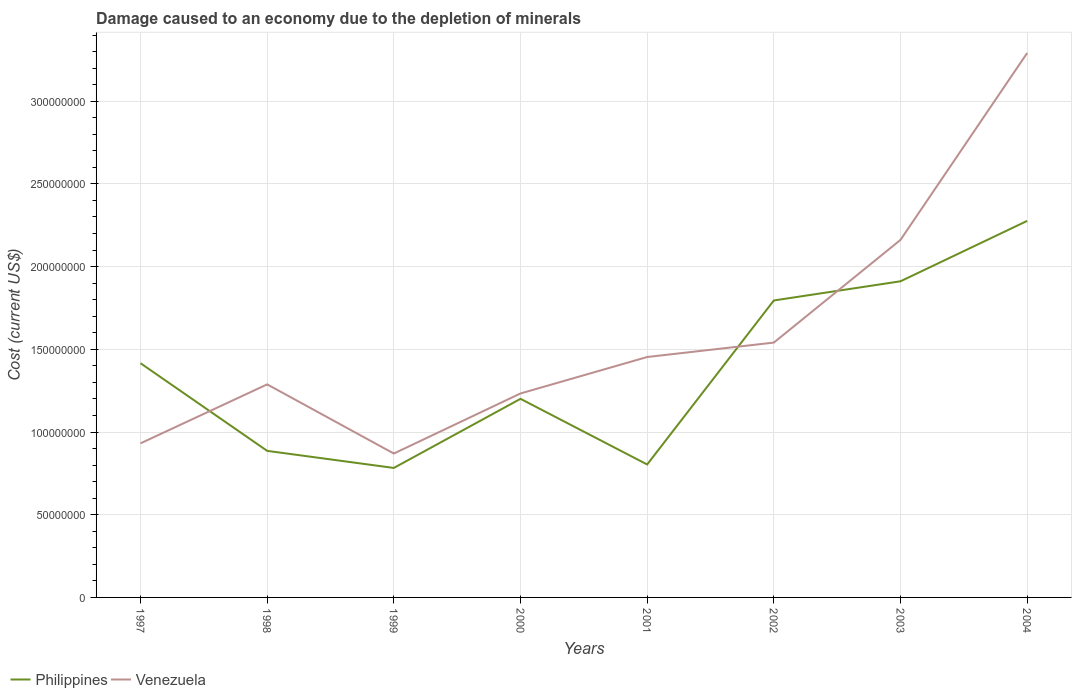Does the line corresponding to Philippines intersect with the line corresponding to Venezuela?
Ensure brevity in your answer.  Yes. Across all years, what is the maximum cost of damage caused due to the depletion of minerals in Philippines?
Ensure brevity in your answer.  7.83e+07. In which year was the cost of damage caused due to the depletion of minerals in Venezuela maximum?
Ensure brevity in your answer.  1999. What is the total cost of damage caused due to the depletion of minerals in Philippines in the graph?
Keep it short and to the point. -4.95e+07. What is the difference between the highest and the second highest cost of damage caused due to the depletion of minerals in Philippines?
Give a very brief answer. 1.49e+08. What is the difference between two consecutive major ticks on the Y-axis?
Give a very brief answer. 5.00e+07. Are the values on the major ticks of Y-axis written in scientific E-notation?
Your response must be concise. No. Does the graph contain any zero values?
Provide a short and direct response. No. Does the graph contain grids?
Your response must be concise. Yes. Where does the legend appear in the graph?
Your answer should be compact. Bottom left. How many legend labels are there?
Your response must be concise. 2. How are the legend labels stacked?
Offer a terse response. Horizontal. What is the title of the graph?
Keep it short and to the point. Damage caused to an economy due to the depletion of minerals. What is the label or title of the Y-axis?
Your answer should be compact. Cost (current US$). What is the Cost (current US$) of Philippines in 1997?
Your response must be concise. 1.42e+08. What is the Cost (current US$) in Venezuela in 1997?
Keep it short and to the point. 9.32e+07. What is the Cost (current US$) of Philippines in 1998?
Ensure brevity in your answer.  8.86e+07. What is the Cost (current US$) of Venezuela in 1998?
Keep it short and to the point. 1.29e+08. What is the Cost (current US$) of Philippines in 1999?
Your answer should be very brief. 7.83e+07. What is the Cost (current US$) of Venezuela in 1999?
Your answer should be very brief. 8.70e+07. What is the Cost (current US$) of Philippines in 2000?
Your response must be concise. 1.20e+08. What is the Cost (current US$) of Venezuela in 2000?
Give a very brief answer. 1.23e+08. What is the Cost (current US$) in Philippines in 2001?
Offer a very short reply. 8.04e+07. What is the Cost (current US$) of Venezuela in 2001?
Give a very brief answer. 1.45e+08. What is the Cost (current US$) in Philippines in 2002?
Give a very brief answer. 1.80e+08. What is the Cost (current US$) of Venezuela in 2002?
Offer a terse response. 1.54e+08. What is the Cost (current US$) of Philippines in 2003?
Your response must be concise. 1.91e+08. What is the Cost (current US$) in Venezuela in 2003?
Provide a succinct answer. 2.16e+08. What is the Cost (current US$) in Philippines in 2004?
Offer a terse response. 2.28e+08. What is the Cost (current US$) in Venezuela in 2004?
Your answer should be compact. 3.29e+08. Across all years, what is the maximum Cost (current US$) in Philippines?
Offer a terse response. 2.28e+08. Across all years, what is the maximum Cost (current US$) of Venezuela?
Offer a very short reply. 3.29e+08. Across all years, what is the minimum Cost (current US$) of Philippines?
Make the answer very short. 7.83e+07. Across all years, what is the minimum Cost (current US$) in Venezuela?
Keep it short and to the point. 8.70e+07. What is the total Cost (current US$) in Philippines in the graph?
Offer a terse response. 1.11e+09. What is the total Cost (current US$) in Venezuela in the graph?
Offer a terse response. 1.28e+09. What is the difference between the Cost (current US$) of Philippines in 1997 and that in 1998?
Your answer should be very brief. 5.30e+07. What is the difference between the Cost (current US$) of Venezuela in 1997 and that in 1998?
Provide a short and direct response. -3.57e+07. What is the difference between the Cost (current US$) in Philippines in 1997 and that in 1999?
Provide a succinct answer. 6.33e+07. What is the difference between the Cost (current US$) in Venezuela in 1997 and that in 1999?
Give a very brief answer. 6.16e+06. What is the difference between the Cost (current US$) in Philippines in 1997 and that in 2000?
Give a very brief answer. 2.15e+07. What is the difference between the Cost (current US$) of Venezuela in 1997 and that in 2000?
Your answer should be very brief. -3.02e+07. What is the difference between the Cost (current US$) in Philippines in 1997 and that in 2001?
Give a very brief answer. 6.12e+07. What is the difference between the Cost (current US$) in Venezuela in 1997 and that in 2001?
Keep it short and to the point. -5.22e+07. What is the difference between the Cost (current US$) in Philippines in 1997 and that in 2002?
Offer a very short reply. -3.79e+07. What is the difference between the Cost (current US$) of Venezuela in 1997 and that in 2002?
Ensure brevity in your answer.  -6.09e+07. What is the difference between the Cost (current US$) in Philippines in 1997 and that in 2003?
Give a very brief answer. -4.95e+07. What is the difference between the Cost (current US$) of Venezuela in 1997 and that in 2003?
Provide a short and direct response. -1.23e+08. What is the difference between the Cost (current US$) of Philippines in 1997 and that in 2004?
Give a very brief answer. -8.60e+07. What is the difference between the Cost (current US$) in Venezuela in 1997 and that in 2004?
Ensure brevity in your answer.  -2.36e+08. What is the difference between the Cost (current US$) of Philippines in 1998 and that in 1999?
Make the answer very short. 1.03e+07. What is the difference between the Cost (current US$) of Venezuela in 1998 and that in 1999?
Provide a short and direct response. 4.18e+07. What is the difference between the Cost (current US$) in Philippines in 1998 and that in 2000?
Make the answer very short. -3.15e+07. What is the difference between the Cost (current US$) in Venezuela in 1998 and that in 2000?
Provide a short and direct response. 5.49e+06. What is the difference between the Cost (current US$) in Philippines in 1998 and that in 2001?
Make the answer very short. 8.23e+06. What is the difference between the Cost (current US$) in Venezuela in 1998 and that in 2001?
Give a very brief answer. -1.65e+07. What is the difference between the Cost (current US$) in Philippines in 1998 and that in 2002?
Ensure brevity in your answer.  -9.09e+07. What is the difference between the Cost (current US$) of Venezuela in 1998 and that in 2002?
Keep it short and to the point. -2.53e+07. What is the difference between the Cost (current US$) of Philippines in 1998 and that in 2003?
Your response must be concise. -1.03e+08. What is the difference between the Cost (current US$) of Venezuela in 1998 and that in 2003?
Ensure brevity in your answer.  -8.74e+07. What is the difference between the Cost (current US$) of Philippines in 1998 and that in 2004?
Offer a terse response. -1.39e+08. What is the difference between the Cost (current US$) in Venezuela in 1998 and that in 2004?
Provide a succinct answer. -2.00e+08. What is the difference between the Cost (current US$) in Philippines in 1999 and that in 2000?
Your response must be concise. -4.18e+07. What is the difference between the Cost (current US$) in Venezuela in 1999 and that in 2000?
Ensure brevity in your answer.  -3.63e+07. What is the difference between the Cost (current US$) in Philippines in 1999 and that in 2001?
Ensure brevity in your answer.  -2.09e+06. What is the difference between the Cost (current US$) of Venezuela in 1999 and that in 2001?
Your answer should be compact. -5.84e+07. What is the difference between the Cost (current US$) of Philippines in 1999 and that in 2002?
Offer a very short reply. -1.01e+08. What is the difference between the Cost (current US$) of Venezuela in 1999 and that in 2002?
Keep it short and to the point. -6.71e+07. What is the difference between the Cost (current US$) in Philippines in 1999 and that in 2003?
Ensure brevity in your answer.  -1.13e+08. What is the difference between the Cost (current US$) in Venezuela in 1999 and that in 2003?
Keep it short and to the point. -1.29e+08. What is the difference between the Cost (current US$) of Philippines in 1999 and that in 2004?
Provide a succinct answer. -1.49e+08. What is the difference between the Cost (current US$) in Venezuela in 1999 and that in 2004?
Your answer should be very brief. -2.42e+08. What is the difference between the Cost (current US$) in Philippines in 2000 and that in 2001?
Your answer should be compact. 3.97e+07. What is the difference between the Cost (current US$) in Venezuela in 2000 and that in 2001?
Offer a very short reply. -2.20e+07. What is the difference between the Cost (current US$) of Philippines in 2000 and that in 2002?
Make the answer very short. -5.95e+07. What is the difference between the Cost (current US$) of Venezuela in 2000 and that in 2002?
Offer a terse response. -3.08e+07. What is the difference between the Cost (current US$) in Philippines in 2000 and that in 2003?
Your answer should be compact. -7.11e+07. What is the difference between the Cost (current US$) of Venezuela in 2000 and that in 2003?
Make the answer very short. -9.28e+07. What is the difference between the Cost (current US$) of Philippines in 2000 and that in 2004?
Offer a terse response. -1.08e+08. What is the difference between the Cost (current US$) in Venezuela in 2000 and that in 2004?
Ensure brevity in your answer.  -2.06e+08. What is the difference between the Cost (current US$) in Philippines in 2001 and that in 2002?
Make the answer very short. -9.92e+07. What is the difference between the Cost (current US$) of Venezuela in 2001 and that in 2002?
Your answer should be compact. -8.72e+06. What is the difference between the Cost (current US$) in Philippines in 2001 and that in 2003?
Your answer should be compact. -1.11e+08. What is the difference between the Cost (current US$) of Venezuela in 2001 and that in 2003?
Your response must be concise. -7.08e+07. What is the difference between the Cost (current US$) of Philippines in 2001 and that in 2004?
Your answer should be compact. -1.47e+08. What is the difference between the Cost (current US$) in Venezuela in 2001 and that in 2004?
Offer a very short reply. -1.84e+08. What is the difference between the Cost (current US$) in Philippines in 2002 and that in 2003?
Offer a terse response. -1.16e+07. What is the difference between the Cost (current US$) in Venezuela in 2002 and that in 2003?
Keep it short and to the point. -6.21e+07. What is the difference between the Cost (current US$) of Philippines in 2002 and that in 2004?
Your answer should be very brief. -4.81e+07. What is the difference between the Cost (current US$) of Venezuela in 2002 and that in 2004?
Offer a very short reply. -1.75e+08. What is the difference between the Cost (current US$) of Philippines in 2003 and that in 2004?
Give a very brief answer. -3.65e+07. What is the difference between the Cost (current US$) in Venezuela in 2003 and that in 2004?
Keep it short and to the point. -1.13e+08. What is the difference between the Cost (current US$) in Philippines in 1997 and the Cost (current US$) in Venezuela in 1998?
Keep it short and to the point. 1.28e+07. What is the difference between the Cost (current US$) in Philippines in 1997 and the Cost (current US$) in Venezuela in 1999?
Your answer should be compact. 5.46e+07. What is the difference between the Cost (current US$) of Philippines in 1997 and the Cost (current US$) of Venezuela in 2000?
Your response must be concise. 1.83e+07. What is the difference between the Cost (current US$) in Philippines in 1997 and the Cost (current US$) in Venezuela in 2001?
Your answer should be compact. -3.75e+06. What is the difference between the Cost (current US$) in Philippines in 1997 and the Cost (current US$) in Venezuela in 2002?
Ensure brevity in your answer.  -1.25e+07. What is the difference between the Cost (current US$) of Philippines in 1997 and the Cost (current US$) of Venezuela in 2003?
Your answer should be very brief. -7.46e+07. What is the difference between the Cost (current US$) of Philippines in 1997 and the Cost (current US$) of Venezuela in 2004?
Make the answer very short. -1.88e+08. What is the difference between the Cost (current US$) of Philippines in 1998 and the Cost (current US$) of Venezuela in 1999?
Keep it short and to the point. 1.62e+06. What is the difference between the Cost (current US$) in Philippines in 1998 and the Cost (current US$) in Venezuela in 2000?
Provide a succinct answer. -3.47e+07. What is the difference between the Cost (current US$) in Philippines in 1998 and the Cost (current US$) in Venezuela in 2001?
Your answer should be very brief. -5.67e+07. What is the difference between the Cost (current US$) of Philippines in 1998 and the Cost (current US$) of Venezuela in 2002?
Offer a terse response. -6.55e+07. What is the difference between the Cost (current US$) of Philippines in 1998 and the Cost (current US$) of Venezuela in 2003?
Your answer should be very brief. -1.28e+08. What is the difference between the Cost (current US$) of Philippines in 1998 and the Cost (current US$) of Venezuela in 2004?
Provide a short and direct response. -2.41e+08. What is the difference between the Cost (current US$) in Philippines in 1999 and the Cost (current US$) in Venezuela in 2000?
Your answer should be very brief. -4.50e+07. What is the difference between the Cost (current US$) of Philippines in 1999 and the Cost (current US$) of Venezuela in 2001?
Provide a short and direct response. -6.71e+07. What is the difference between the Cost (current US$) of Philippines in 1999 and the Cost (current US$) of Venezuela in 2002?
Make the answer very short. -7.58e+07. What is the difference between the Cost (current US$) in Philippines in 1999 and the Cost (current US$) in Venezuela in 2003?
Offer a very short reply. -1.38e+08. What is the difference between the Cost (current US$) in Philippines in 1999 and the Cost (current US$) in Venezuela in 2004?
Ensure brevity in your answer.  -2.51e+08. What is the difference between the Cost (current US$) in Philippines in 2000 and the Cost (current US$) in Venezuela in 2001?
Your answer should be very brief. -2.53e+07. What is the difference between the Cost (current US$) of Philippines in 2000 and the Cost (current US$) of Venezuela in 2002?
Your response must be concise. -3.40e+07. What is the difference between the Cost (current US$) of Philippines in 2000 and the Cost (current US$) of Venezuela in 2003?
Your answer should be compact. -9.61e+07. What is the difference between the Cost (current US$) of Philippines in 2000 and the Cost (current US$) of Venezuela in 2004?
Provide a short and direct response. -2.09e+08. What is the difference between the Cost (current US$) in Philippines in 2001 and the Cost (current US$) in Venezuela in 2002?
Your answer should be compact. -7.37e+07. What is the difference between the Cost (current US$) of Philippines in 2001 and the Cost (current US$) of Venezuela in 2003?
Your response must be concise. -1.36e+08. What is the difference between the Cost (current US$) in Philippines in 2001 and the Cost (current US$) in Venezuela in 2004?
Give a very brief answer. -2.49e+08. What is the difference between the Cost (current US$) in Philippines in 2002 and the Cost (current US$) in Venezuela in 2003?
Make the answer very short. -3.66e+07. What is the difference between the Cost (current US$) in Philippines in 2002 and the Cost (current US$) in Venezuela in 2004?
Offer a very short reply. -1.50e+08. What is the difference between the Cost (current US$) in Philippines in 2003 and the Cost (current US$) in Venezuela in 2004?
Provide a short and direct response. -1.38e+08. What is the average Cost (current US$) of Philippines per year?
Give a very brief answer. 1.38e+08. What is the average Cost (current US$) in Venezuela per year?
Offer a very short reply. 1.60e+08. In the year 1997, what is the difference between the Cost (current US$) in Philippines and Cost (current US$) in Venezuela?
Keep it short and to the point. 4.85e+07. In the year 1998, what is the difference between the Cost (current US$) of Philippines and Cost (current US$) of Venezuela?
Your answer should be very brief. -4.02e+07. In the year 1999, what is the difference between the Cost (current US$) of Philippines and Cost (current US$) of Venezuela?
Your answer should be compact. -8.71e+06. In the year 2000, what is the difference between the Cost (current US$) of Philippines and Cost (current US$) of Venezuela?
Make the answer very short. -3.25e+06. In the year 2001, what is the difference between the Cost (current US$) of Philippines and Cost (current US$) of Venezuela?
Offer a terse response. -6.50e+07. In the year 2002, what is the difference between the Cost (current US$) of Philippines and Cost (current US$) of Venezuela?
Your answer should be very brief. 2.55e+07. In the year 2003, what is the difference between the Cost (current US$) of Philippines and Cost (current US$) of Venezuela?
Make the answer very short. -2.50e+07. In the year 2004, what is the difference between the Cost (current US$) of Philippines and Cost (current US$) of Venezuela?
Ensure brevity in your answer.  -1.02e+08. What is the ratio of the Cost (current US$) in Philippines in 1997 to that in 1998?
Ensure brevity in your answer.  1.6. What is the ratio of the Cost (current US$) in Venezuela in 1997 to that in 1998?
Your answer should be compact. 0.72. What is the ratio of the Cost (current US$) in Philippines in 1997 to that in 1999?
Make the answer very short. 1.81. What is the ratio of the Cost (current US$) in Venezuela in 1997 to that in 1999?
Offer a terse response. 1.07. What is the ratio of the Cost (current US$) in Philippines in 1997 to that in 2000?
Provide a succinct answer. 1.18. What is the ratio of the Cost (current US$) in Venezuela in 1997 to that in 2000?
Provide a short and direct response. 0.76. What is the ratio of the Cost (current US$) of Philippines in 1997 to that in 2001?
Your response must be concise. 1.76. What is the ratio of the Cost (current US$) of Venezuela in 1997 to that in 2001?
Ensure brevity in your answer.  0.64. What is the ratio of the Cost (current US$) of Philippines in 1997 to that in 2002?
Make the answer very short. 0.79. What is the ratio of the Cost (current US$) in Venezuela in 1997 to that in 2002?
Your answer should be very brief. 0.6. What is the ratio of the Cost (current US$) of Philippines in 1997 to that in 2003?
Give a very brief answer. 0.74. What is the ratio of the Cost (current US$) of Venezuela in 1997 to that in 2003?
Provide a succinct answer. 0.43. What is the ratio of the Cost (current US$) of Philippines in 1997 to that in 2004?
Your response must be concise. 0.62. What is the ratio of the Cost (current US$) in Venezuela in 1997 to that in 2004?
Give a very brief answer. 0.28. What is the ratio of the Cost (current US$) in Philippines in 1998 to that in 1999?
Ensure brevity in your answer.  1.13. What is the ratio of the Cost (current US$) in Venezuela in 1998 to that in 1999?
Give a very brief answer. 1.48. What is the ratio of the Cost (current US$) of Philippines in 1998 to that in 2000?
Offer a terse response. 0.74. What is the ratio of the Cost (current US$) of Venezuela in 1998 to that in 2000?
Keep it short and to the point. 1.04. What is the ratio of the Cost (current US$) of Philippines in 1998 to that in 2001?
Your answer should be very brief. 1.1. What is the ratio of the Cost (current US$) of Venezuela in 1998 to that in 2001?
Your answer should be compact. 0.89. What is the ratio of the Cost (current US$) in Philippines in 1998 to that in 2002?
Give a very brief answer. 0.49. What is the ratio of the Cost (current US$) of Venezuela in 1998 to that in 2002?
Provide a short and direct response. 0.84. What is the ratio of the Cost (current US$) in Philippines in 1998 to that in 2003?
Make the answer very short. 0.46. What is the ratio of the Cost (current US$) of Venezuela in 1998 to that in 2003?
Offer a terse response. 0.6. What is the ratio of the Cost (current US$) of Philippines in 1998 to that in 2004?
Your response must be concise. 0.39. What is the ratio of the Cost (current US$) in Venezuela in 1998 to that in 2004?
Offer a terse response. 0.39. What is the ratio of the Cost (current US$) in Philippines in 1999 to that in 2000?
Your response must be concise. 0.65. What is the ratio of the Cost (current US$) of Venezuela in 1999 to that in 2000?
Provide a succinct answer. 0.71. What is the ratio of the Cost (current US$) of Philippines in 1999 to that in 2001?
Offer a very short reply. 0.97. What is the ratio of the Cost (current US$) of Venezuela in 1999 to that in 2001?
Offer a very short reply. 0.6. What is the ratio of the Cost (current US$) of Philippines in 1999 to that in 2002?
Your answer should be very brief. 0.44. What is the ratio of the Cost (current US$) in Venezuela in 1999 to that in 2002?
Your response must be concise. 0.56. What is the ratio of the Cost (current US$) in Philippines in 1999 to that in 2003?
Your answer should be compact. 0.41. What is the ratio of the Cost (current US$) of Venezuela in 1999 to that in 2003?
Offer a very short reply. 0.4. What is the ratio of the Cost (current US$) in Philippines in 1999 to that in 2004?
Make the answer very short. 0.34. What is the ratio of the Cost (current US$) in Venezuela in 1999 to that in 2004?
Give a very brief answer. 0.26. What is the ratio of the Cost (current US$) of Philippines in 2000 to that in 2001?
Your answer should be compact. 1.49. What is the ratio of the Cost (current US$) in Venezuela in 2000 to that in 2001?
Your answer should be very brief. 0.85. What is the ratio of the Cost (current US$) in Philippines in 2000 to that in 2002?
Provide a short and direct response. 0.67. What is the ratio of the Cost (current US$) in Venezuela in 2000 to that in 2002?
Provide a succinct answer. 0.8. What is the ratio of the Cost (current US$) in Philippines in 2000 to that in 2003?
Provide a succinct answer. 0.63. What is the ratio of the Cost (current US$) in Venezuela in 2000 to that in 2003?
Provide a succinct answer. 0.57. What is the ratio of the Cost (current US$) of Philippines in 2000 to that in 2004?
Make the answer very short. 0.53. What is the ratio of the Cost (current US$) in Venezuela in 2000 to that in 2004?
Keep it short and to the point. 0.37. What is the ratio of the Cost (current US$) of Philippines in 2001 to that in 2002?
Your answer should be compact. 0.45. What is the ratio of the Cost (current US$) in Venezuela in 2001 to that in 2002?
Offer a very short reply. 0.94. What is the ratio of the Cost (current US$) of Philippines in 2001 to that in 2003?
Provide a succinct answer. 0.42. What is the ratio of the Cost (current US$) in Venezuela in 2001 to that in 2003?
Provide a short and direct response. 0.67. What is the ratio of the Cost (current US$) of Philippines in 2001 to that in 2004?
Provide a short and direct response. 0.35. What is the ratio of the Cost (current US$) in Venezuela in 2001 to that in 2004?
Offer a terse response. 0.44. What is the ratio of the Cost (current US$) of Philippines in 2002 to that in 2003?
Make the answer very short. 0.94. What is the ratio of the Cost (current US$) of Venezuela in 2002 to that in 2003?
Keep it short and to the point. 0.71. What is the ratio of the Cost (current US$) of Philippines in 2002 to that in 2004?
Offer a terse response. 0.79. What is the ratio of the Cost (current US$) of Venezuela in 2002 to that in 2004?
Offer a terse response. 0.47. What is the ratio of the Cost (current US$) of Philippines in 2003 to that in 2004?
Make the answer very short. 0.84. What is the ratio of the Cost (current US$) of Venezuela in 2003 to that in 2004?
Offer a terse response. 0.66. What is the difference between the highest and the second highest Cost (current US$) of Philippines?
Make the answer very short. 3.65e+07. What is the difference between the highest and the second highest Cost (current US$) in Venezuela?
Make the answer very short. 1.13e+08. What is the difference between the highest and the lowest Cost (current US$) of Philippines?
Provide a succinct answer. 1.49e+08. What is the difference between the highest and the lowest Cost (current US$) of Venezuela?
Give a very brief answer. 2.42e+08. 